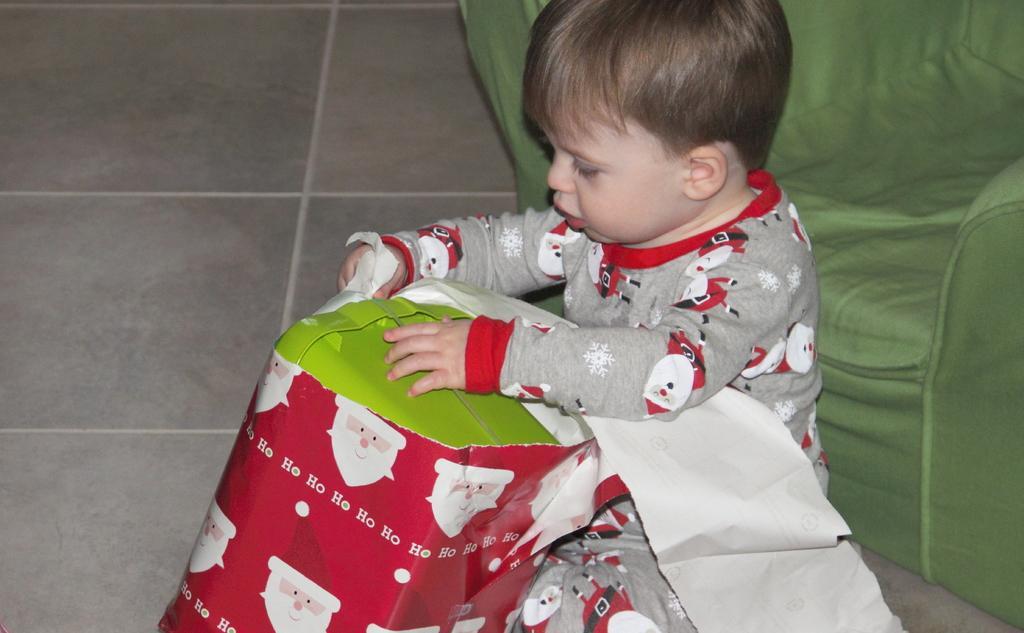Describe this image in one or two sentences. In this image, we can see a kid wearing clothes and holding a box. There is a sofa on the right side of the image. 